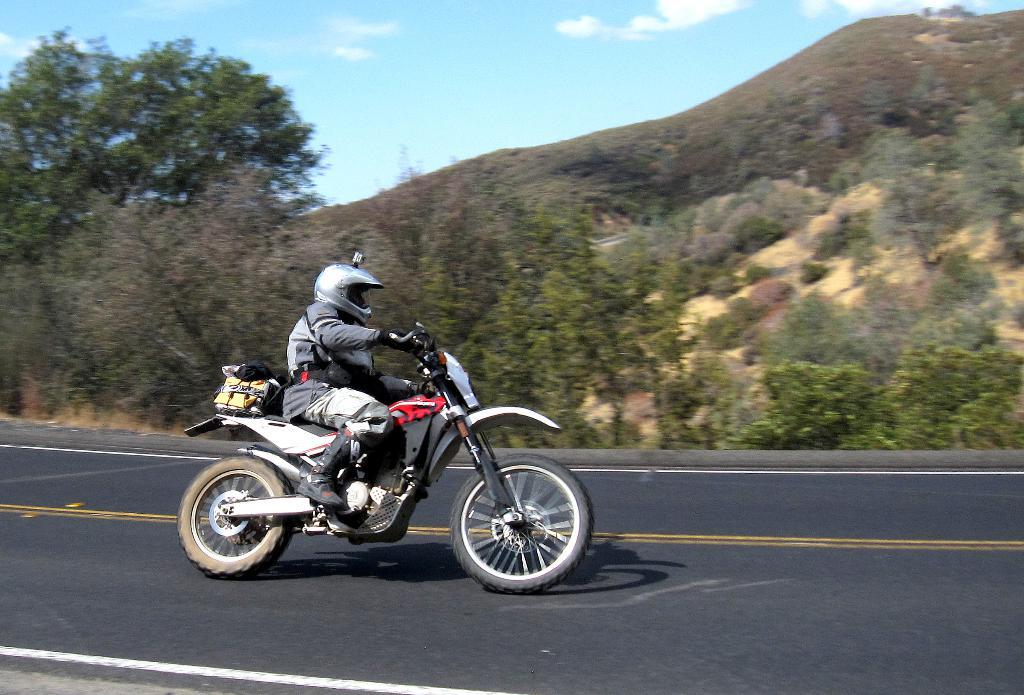What is the person in the image doing? The person is riding a bike in the image. What is the person wearing while riding the bike? The person is wearing a helmet. Where is the bike located? The bike is on a road. What can be seen in the background of the image? There are trees, mountains, and the sky visible in the background. What is the condition of the sky in the image? The sky has clouds present in it. What type of cakes can be seen in the image? There are no cakes present in the image. What color are the person's teeth while riding the bike? The image does not show the person's teeth, so it cannot be determined what color they are. 